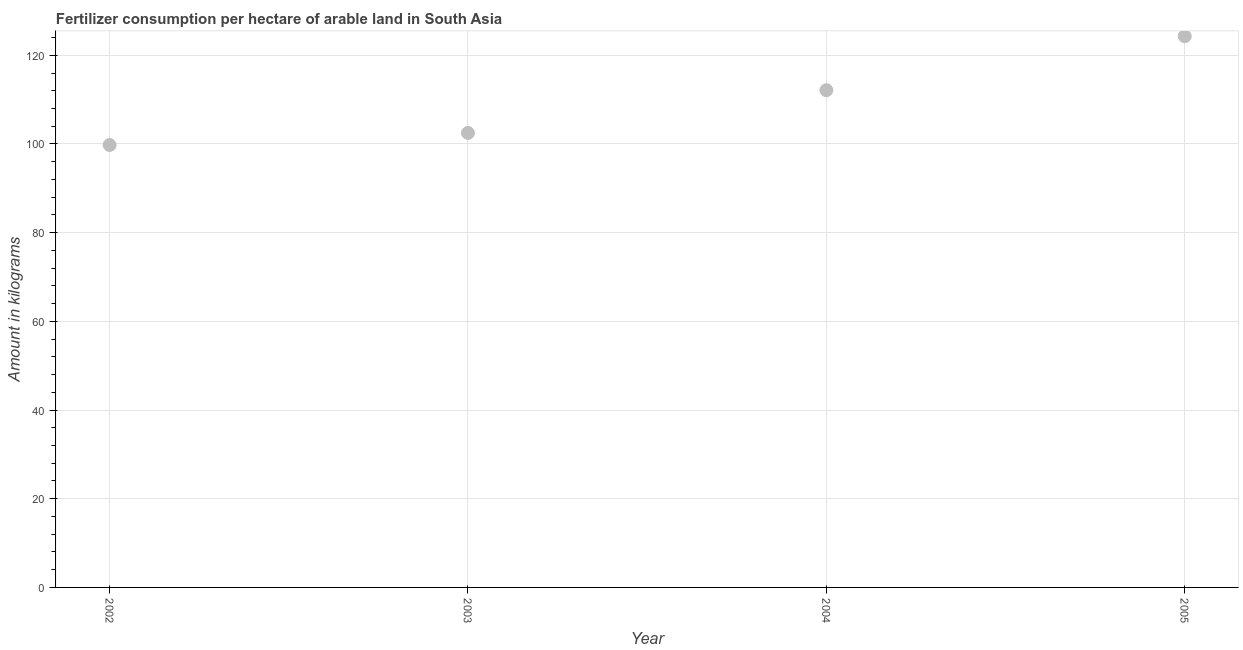What is the amount of fertilizer consumption in 2003?
Keep it short and to the point. 102.49. Across all years, what is the maximum amount of fertilizer consumption?
Keep it short and to the point. 124.29. Across all years, what is the minimum amount of fertilizer consumption?
Make the answer very short. 99.76. In which year was the amount of fertilizer consumption minimum?
Ensure brevity in your answer.  2002. What is the sum of the amount of fertilizer consumption?
Your answer should be very brief. 438.65. What is the difference between the amount of fertilizer consumption in 2002 and 2005?
Make the answer very short. -24.52. What is the average amount of fertilizer consumption per year?
Your answer should be very brief. 109.66. What is the median amount of fertilizer consumption?
Provide a short and direct response. 107.3. In how many years, is the amount of fertilizer consumption greater than 48 kg?
Provide a succinct answer. 4. What is the ratio of the amount of fertilizer consumption in 2004 to that in 2005?
Give a very brief answer. 0.9. Is the amount of fertilizer consumption in 2004 less than that in 2005?
Ensure brevity in your answer.  Yes. What is the difference between the highest and the second highest amount of fertilizer consumption?
Make the answer very short. 12.17. What is the difference between the highest and the lowest amount of fertilizer consumption?
Give a very brief answer. 24.52. Does the amount of fertilizer consumption monotonically increase over the years?
Offer a very short reply. Yes. What is the difference between two consecutive major ticks on the Y-axis?
Give a very brief answer. 20. Does the graph contain grids?
Keep it short and to the point. Yes. What is the title of the graph?
Give a very brief answer. Fertilizer consumption per hectare of arable land in South Asia . What is the label or title of the Y-axis?
Keep it short and to the point. Amount in kilograms. What is the Amount in kilograms in 2002?
Offer a terse response. 99.76. What is the Amount in kilograms in 2003?
Your answer should be compact. 102.49. What is the Amount in kilograms in 2004?
Your answer should be very brief. 112.12. What is the Amount in kilograms in 2005?
Your answer should be compact. 124.29. What is the difference between the Amount in kilograms in 2002 and 2003?
Ensure brevity in your answer.  -2.72. What is the difference between the Amount in kilograms in 2002 and 2004?
Ensure brevity in your answer.  -12.35. What is the difference between the Amount in kilograms in 2002 and 2005?
Offer a very short reply. -24.52. What is the difference between the Amount in kilograms in 2003 and 2004?
Your answer should be very brief. -9.63. What is the difference between the Amount in kilograms in 2003 and 2005?
Offer a very short reply. -21.8. What is the difference between the Amount in kilograms in 2004 and 2005?
Provide a short and direct response. -12.17. What is the ratio of the Amount in kilograms in 2002 to that in 2004?
Ensure brevity in your answer.  0.89. What is the ratio of the Amount in kilograms in 2002 to that in 2005?
Your response must be concise. 0.8. What is the ratio of the Amount in kilograms in 2003 to that in 2004?
Offer a terse response. 0.91. What is the ratio of the Amount in kilograms in 2003 to that in 2005?
Provide a short and direct response. 0.82. What is the ratio of the Amount in kilograms in 2004 to that in 2005?
Ensure brevity in your answer.  0.9. 